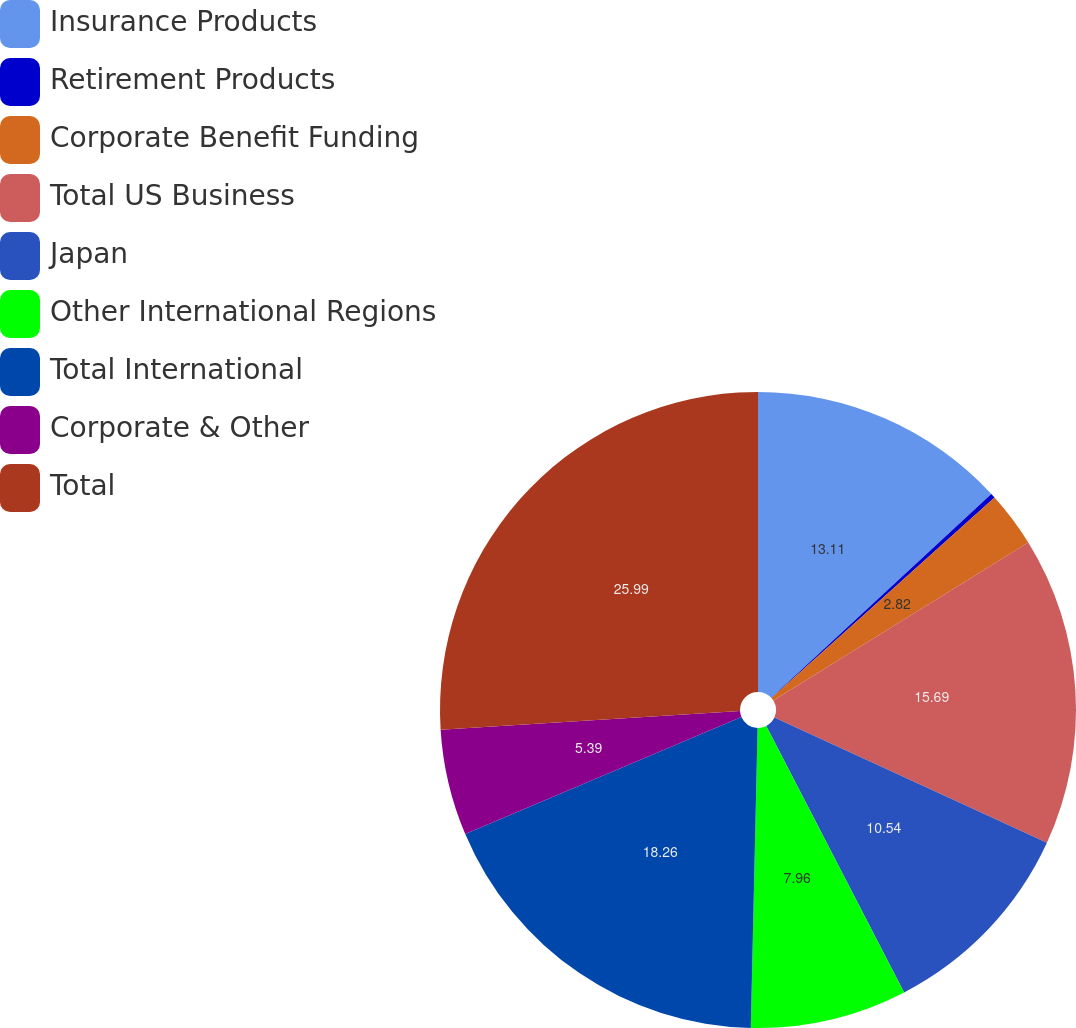Convert chart. <chart><loc_0><loc_0><loc_500><loc_500><pie_chart><fcel>Insurance Products<fcel>Retirement Products<fcel>Corporate Benefit Funding<fcel>Total US Business<fcel>Japan<fcel>Other International Regions<fcel>Total International<fcel>Corporate & Other<fcel>Total<nl><fcel>13.11%<fcel>0.24%<fcel>2.82%<fcel>15.69%<fcel>10.54%<fcel>7.96%<fcel>18.26%<fcel>5.39%<fcel>25.99%<nl></chart> 